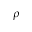Convert formula to latex. <formula><loc_0><loc_0><loc_500><loc_500>\rho</formula> 